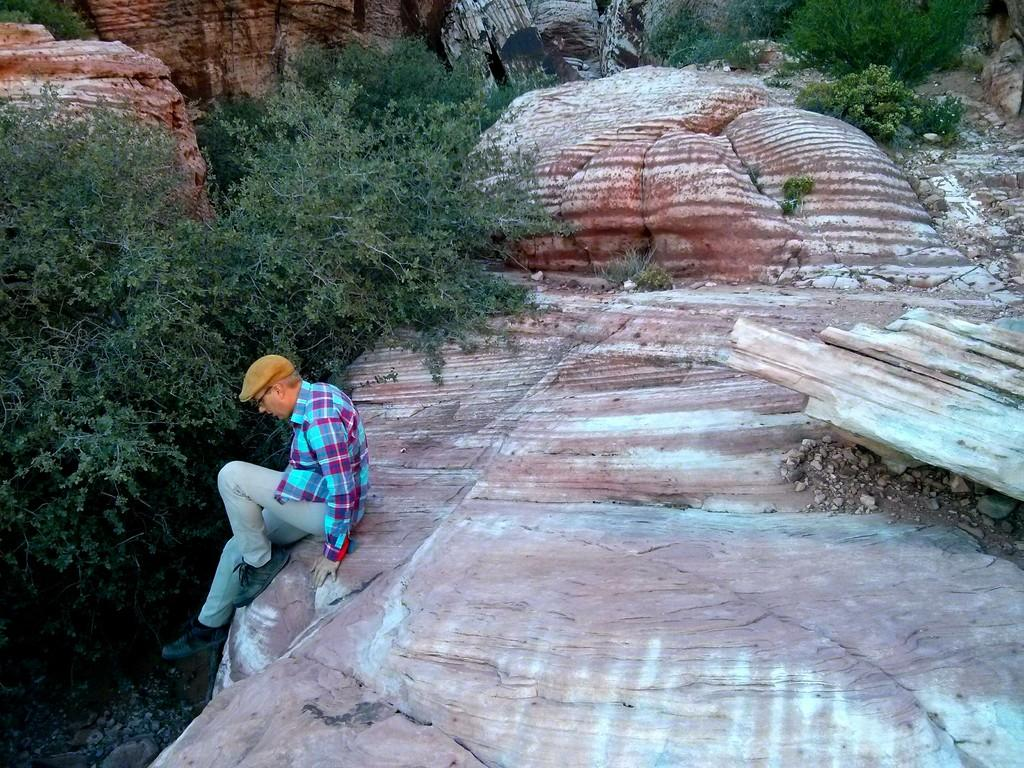Who or what is the main subject in the image? There is a person in the image. Where is the person located? The person is on a rock. What can be seen in the vicinity of the rocks? There are trees and plants near the rocks. How many friends are present with the person in the image? There is no indication of friends in the image; only the person on the rock is visible. 